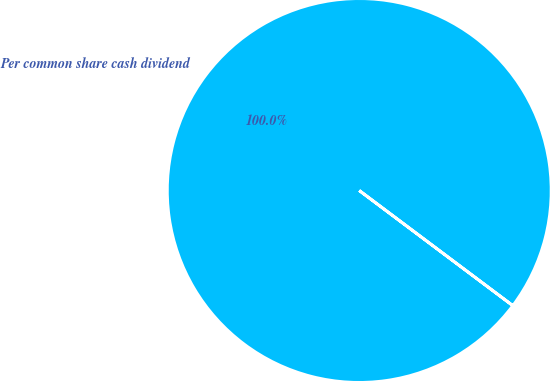Convert chart. <chart><loc_0><loc_0><loc_500><loc_500><pie_chart><fcel>Per common share cash dividend<nl><fcel>100.0%<nl></chart> 